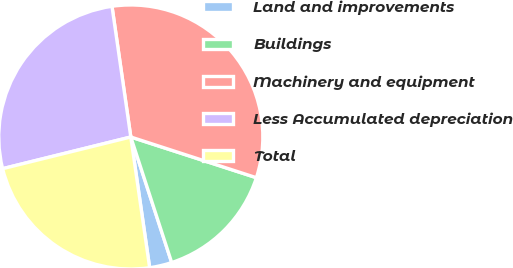<chart> <loc_0><loc_0><loc_500><loc_500><pie_chart><fcel>Land and improvements<fcel>Buildings<fcel>Machinery and equipment<fcel>Less Accumulated depreciation<fcel>Total<nl><fcel>2.73%<fcel>15.0%<fcel>32.26%<fcel>26.58%<fcel>23.42%<nl></chart> 